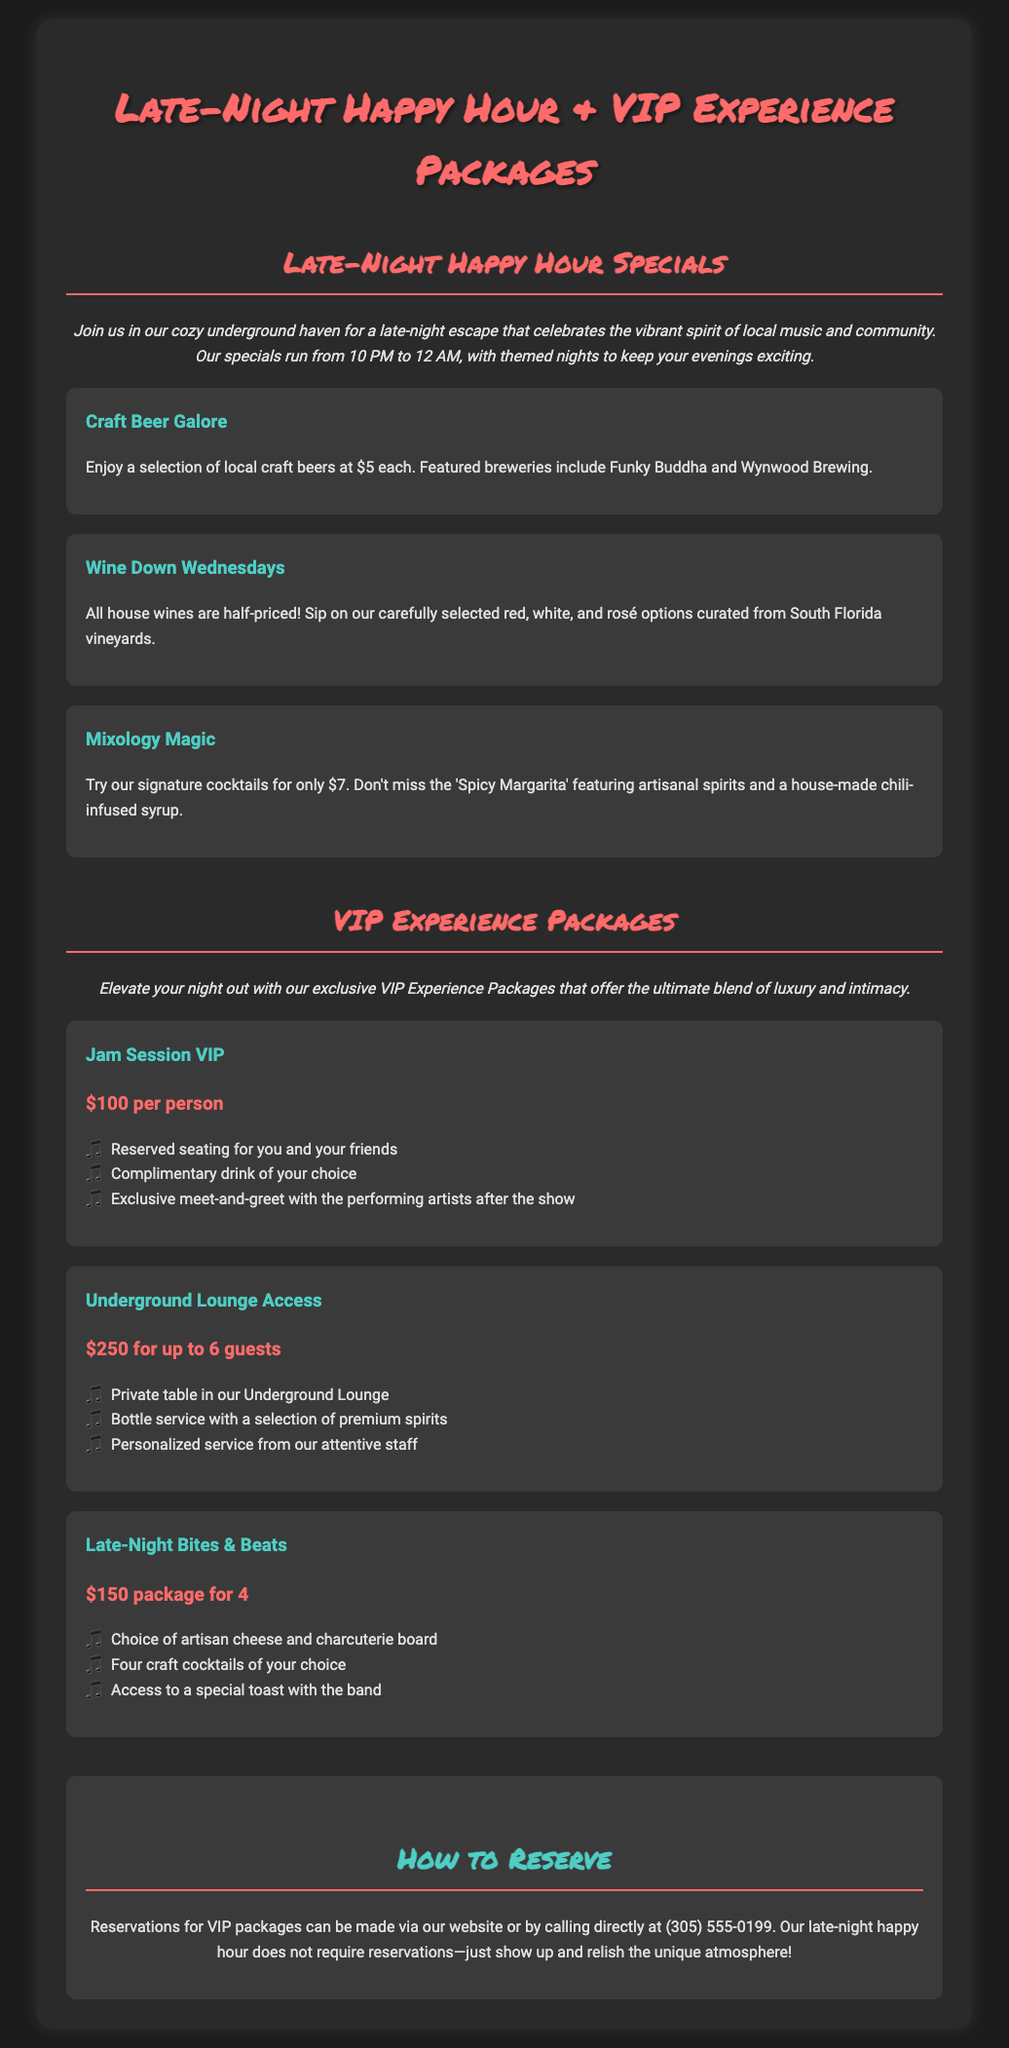what time does the late-night happy hour start? The late-night happy hour starts at 10 PM.
Answer: 10 PM how much is the craft beer during the happy hour? The craft beer is priced at $5 each during the happy hour.
Answer: $5 what is included in the Jam Session VIP package? The Jam Session VIP package includes reserved seating, a complimentary drink, and a meet-and-greet with the performing artists.
Answer: Reserved seating, complimentary drink, meet-and-greet how many guests can the Underground Lounge Access package accommodate? The Underground Lounge Access package can accommodate up to 6 guests.
Answer: 6 guests what is the price for the Late-Night Bites & Beats package? The price for the Late-Night Bites & Beats package is $150.
Answer: $150 is a reservation required for the late-night happy hour? The late-night happy hour does not require reservations, just show up.
Answer: No what special feature does the Mixology Magic promotion offer? The Mixology Magic promotion offers signature cocktails for $7.
Answer: Signature cocktails for $7 how can VIP package reservations be made? VIP package reservations can be made via the website or by calling directly.
Answer: Via website or phone 